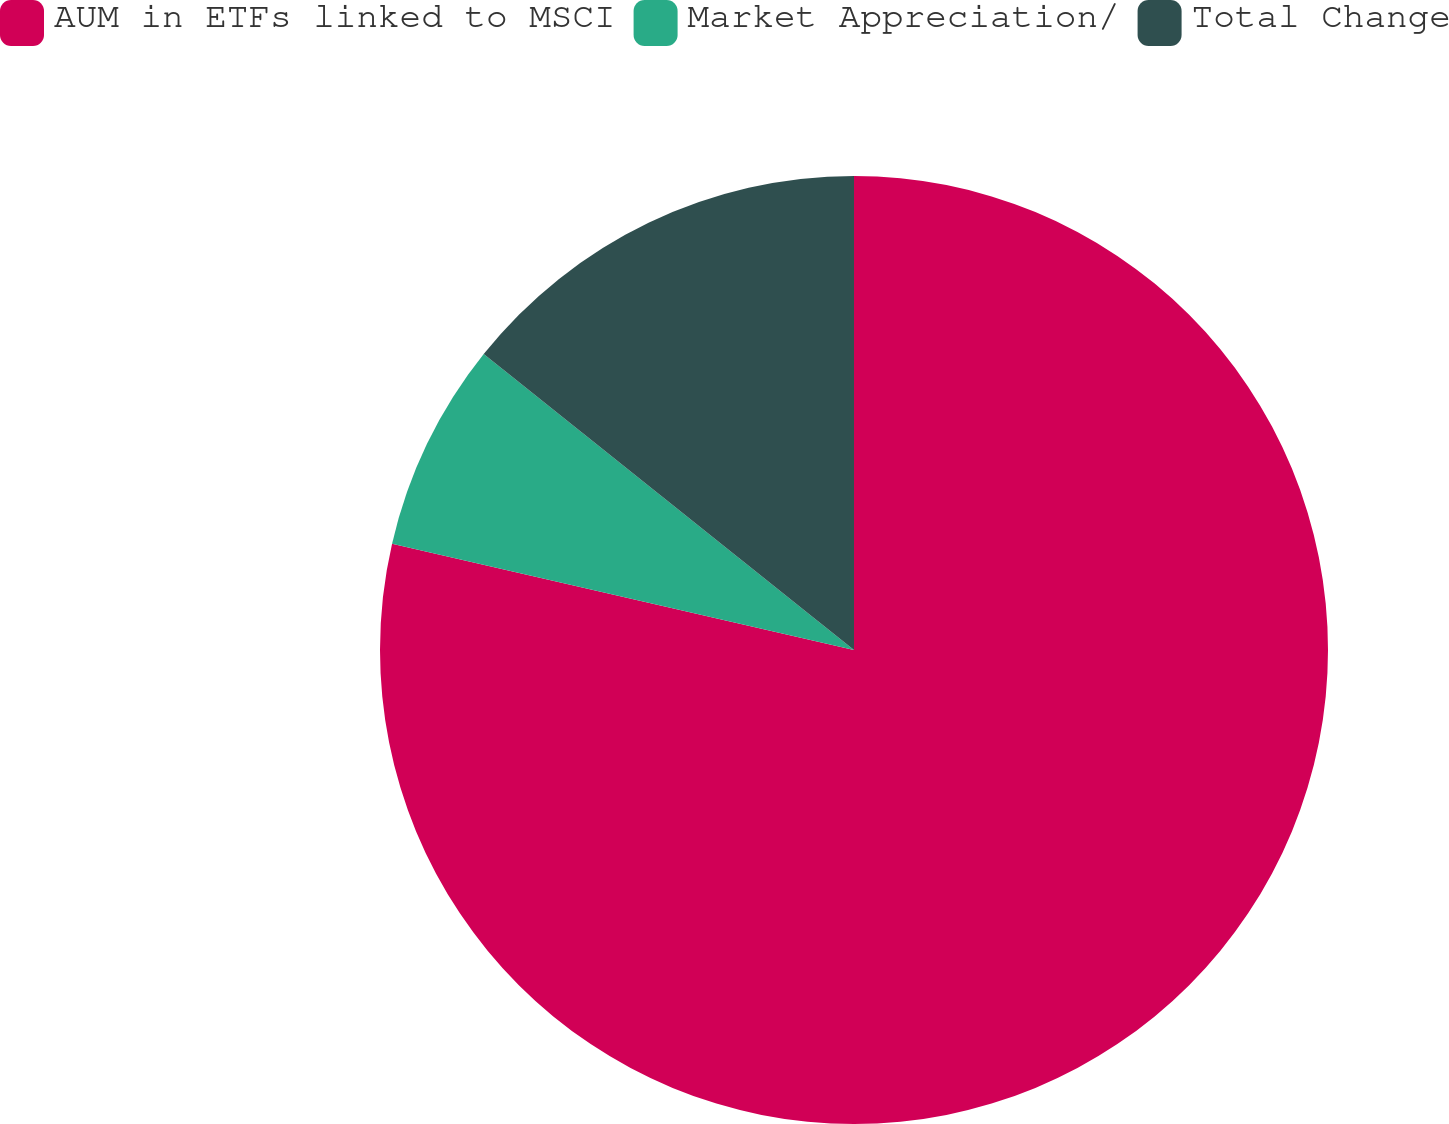Convert chart to OTSL. <chart><loc_0><loc_0><loc_500><loc_500><pie_chart><fcel>AUM in ETFs linked to MSCI<fcel>Market Appreciation/<fcel>Total Change<nl><fcel>78.6%<fcel>7.13%<fcel>14.27%<nl></chart> 